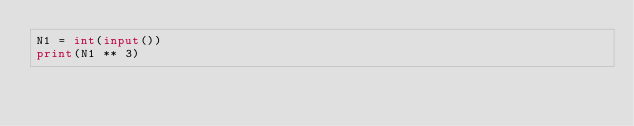Convert code to text. <code><loc_0><loc_0><loc_500><loc_500><_Python_>N1 = int(input())
print(N1 ** 3)</code> 